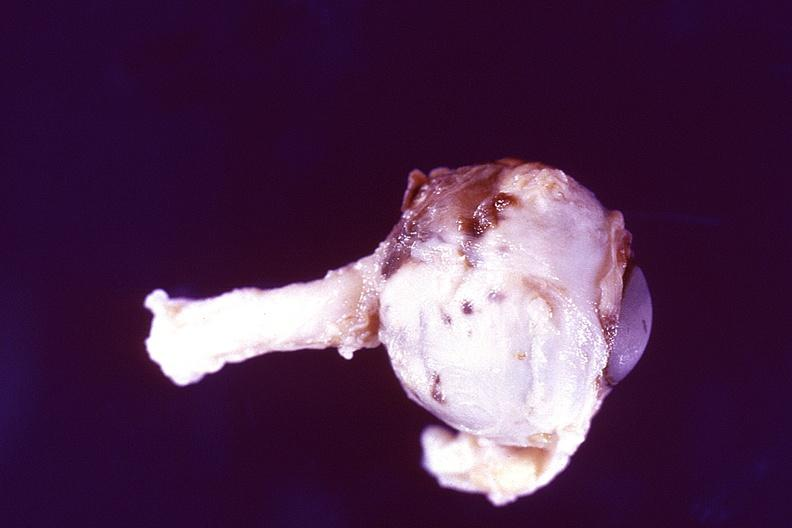what does this image show?
Answer the question using a single word or phrase. Disseminated intravascular coagulation dic 